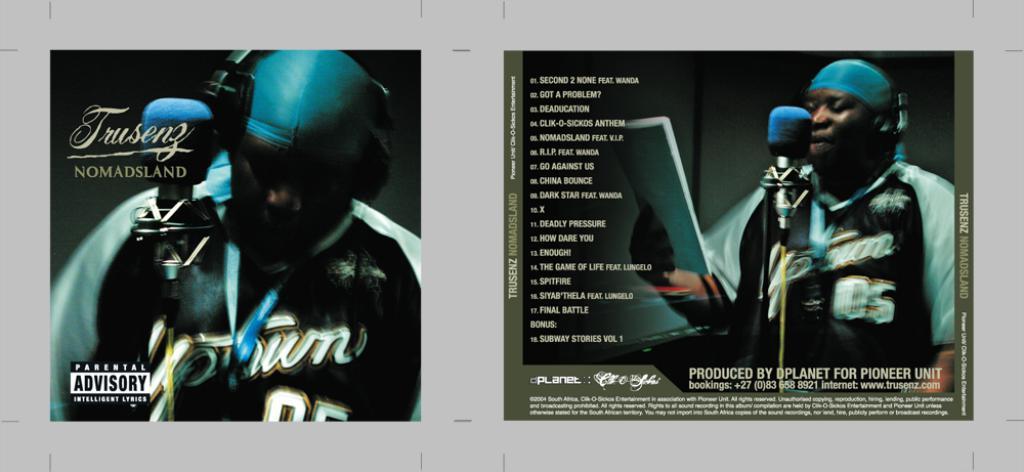What does the warning say on the left corner?
Provide a short and direct response. Parental advisory. What is the album called?
Ensure brevity in your answer.  Nomadsland. 